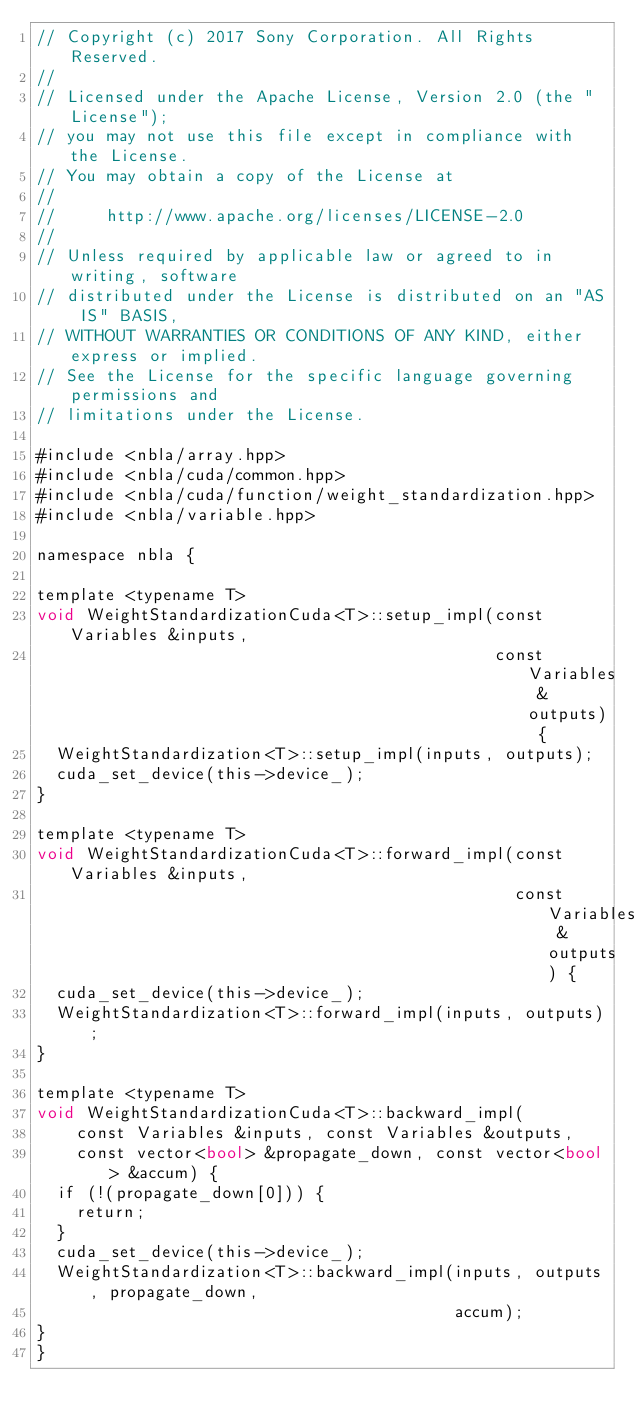<code> <loc_0><loc_0><loc_500><loc_500><_Cuda_>// Copyright (c) 2017 Sony Corporation. All Rights Reserved.
//
// Licensed under the Apache License, Version 2.0 (the "License");
// you may not use this file except in compliance with the License.
// You may obtain a copy of the License at
//
//     http://www.apache.org/licenses/LICENSE-2.0
//
// Unless required by applicable law or agreed to in writing, software
// distributed under the License is distributed on an "AS IS" BASIS,
// WITHOUT WARRANTIES OR CONDITIONS OF ANY KIND, either express or implied.
// See the License for the specific language governing permissions and
// limitations under the License.

#include <nbla/array.hpp>
#include <nbla/cuda/common.hpp>
#include <nbla/cuda/function/weight_standardization.hpp>
#include <nbla/variable.hpp>

namespace nbla {

template <typename T>
void WeightStandardizationCuda<T>::setup_impl(const Variables &inputs,
                                              const Variables &outputs) {
  WeightStandardization<T>::setup_impl(inputs, outputs);
  cuda_set_device(this->device_);
}

template <typename T>
void WeightStandardizationCuda<T>::forward_impl(const Variables &inputs,
                                                const Variables &outputs) {
  cuda_set_device(this->device_);
  WeightStandardization<T>::forward_impl(inputs, outputs);
}

template <typename T>
void WeightStandardizationCuda<T>::backward_impl(
    const Variables &inputs, const Variables &outputs,
    const vector<bool> &propagate_down, const vector<bool> &accum) {
  if (!(propagate_down[0])) {
    return;
  }
  cuda_set_device(this->device_);
  WeightStandardization<T>::backward_impl(inputs, outputs, propagate_down,
                                          accum);
}
}
</code> 